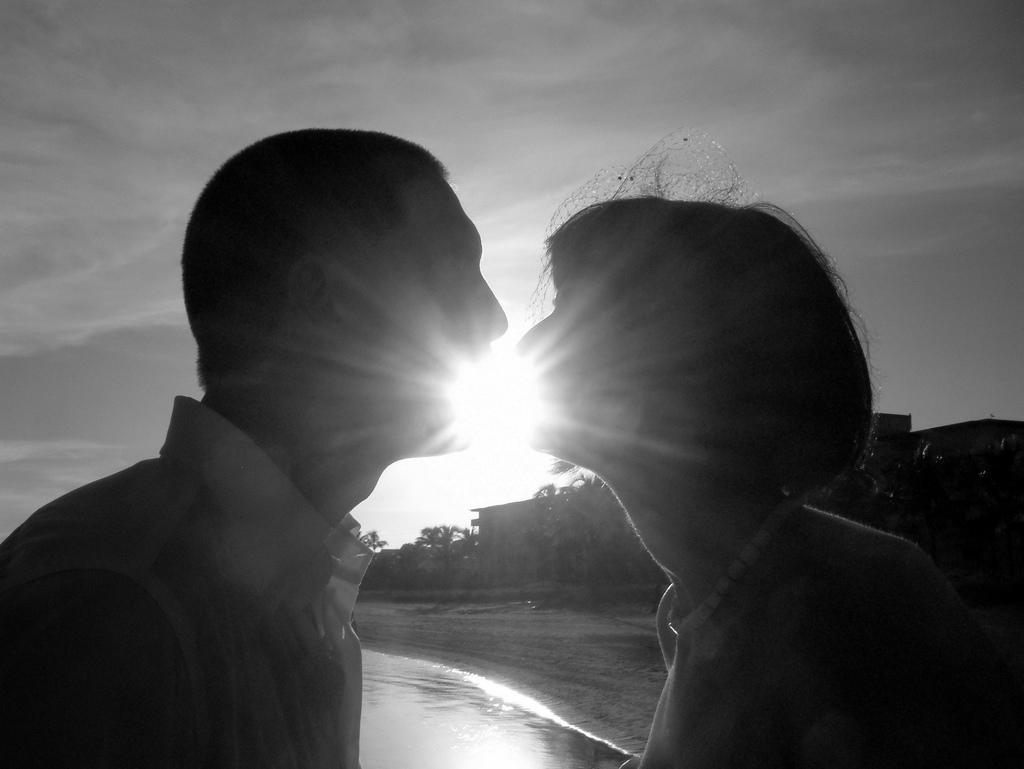Describe this image in one or two sentences. This picture might be taken outside of the city. In this image, we can see two people man and woman. In the background, we can see some trees, buildings. At the top, we can see a sky which is cloudy, at the bottom, we can see a water in a lake and a sand. 